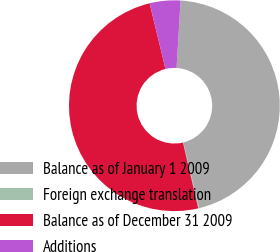<chart> <loc_0><loc_0><loc_500><loc_500><pie_chart><fcel>Balance as of January 1 2009<fcel>Foreign exchange translation<fcel>Balance as of December 31 2009<fcel>Additions<nl><fcel>45.29%<fcel>0.14%<fcel>49.86%<fcel>4.71%<nl></chart> 